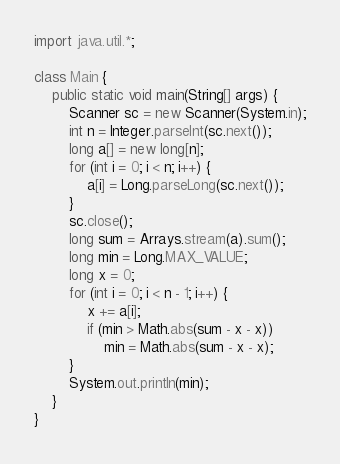<code> <loc_0><loc_0><loc_500><loc_500><_Java_>import java.util.*;

class Main {
    public static void main(String[] args) {
        Scanner sc = new Scanner(System.in);
        int n = Integer.parseInt(sc.next());
        long a[] = new long[n];
        for (int i = 0; i < n; i++) {
            a[i] = Long.parseLong(sc.next());
        }
        sc.close();
        long sum = Arrays.stream(a).sum();
        long min = Long.MAX_VALUE;
        long x = 0;
        for (int i = 0; i < n - 1; i++) {
            x += a[i];
            if (min > Math.abs(sum - x - x))
                min = Math.abs(sum - x - x);
        }
        System.out.println(min);
    }
}</code> 